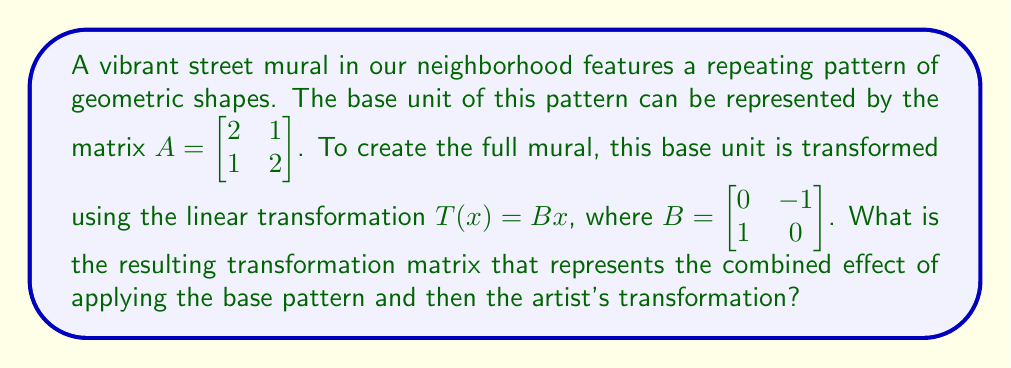Provide a solution to this math problem. To find the resulting transformation matrix, we need to compose the two transformations:

1) First, we apply the base pattern transformation represented by matrix $A$.
2) Then, we apply the artist's transformation represented by matrix $B$.

The composition of these transformations is given by the matrix product $BA$:

$$BA = \begin{bmatrix} 0 & -1 \\ 1 & 0 \end{bmatrix} \begin{bmatrix} 2 & 1 \\ 1 & 2 \end{bmatrix}$$

Let's multiply these matrices:

$$\begin{aligned}
BA &= \begin{bmatrix} 
(0 \cdot 2 + (-1) \cdot 1) & (0 \cdot 1 + (-1) \cdot 2) \\
(1 \cdot 2 + 0 \cdot 1) & (1 \cdot 1 + 0 \cdot 2)
\end{bmatrix} \\[2ex]
&= \begin{bmatrix} 
-1 & -2 \\
2 & 1
\end{bmatrix}
\end{aligned}$$

This resulting matrix represents the combined effect of applying the base pattern and then the artist's transformation.
Answer: $\begin{bmatrix} -1 & -2 \\ 2 & 1 \end{bmatrix}$ 